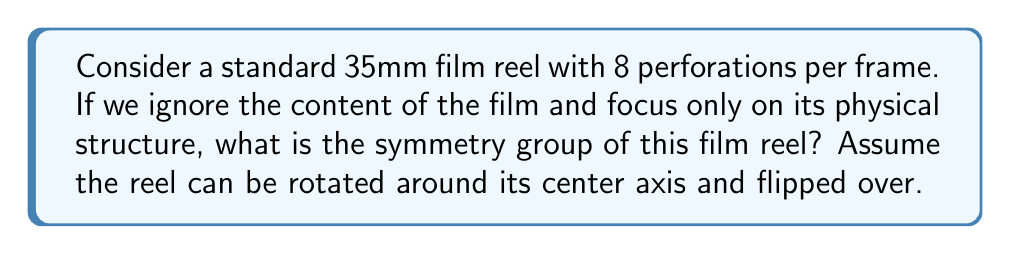Can you answer this question? Let's approach this step-by-step:

1) First, we need to consider the symmetries of the film reel:

   a) Rotational symmetry: The film reel can be rotated around its center axis. Each frame is identical in structure (8 perforations), so rotating by one frame results in the same configuration.

   b) Reflection symmetry: The reel can be flipped over (reflected across its diameter).

2) Let's define our group elements:

   - $e$: Identity (no movement)
   - $r$: Rotation by one frame
   - $f$: Flip (reflection)

3) Properties of these elements:

   - $r^n = e$, where $n$ is the number of frames in the reel
   - $f^2 = e$ (flipping twice returns to the original state)
   - $fr = r^{-1}f$ (flipping then rotating is equivalent to rotating in the opposite direction then flipping)

4) This group structure is known as the Dihedral group $D_n$, where $n$ is the number of frames in the reel.

5) The order of this group is $2n$, as there are $n$ rotations and $n$ rotations followed by a flip.

6) While we don't know the exact number of frames in the reel, we can represent it as $D_n$ where $n$ is the number of frames.
Answer: The symmetry group of the film reel is the Dihedral group $D_n$, where $n$ is the number of frames in the reel. 